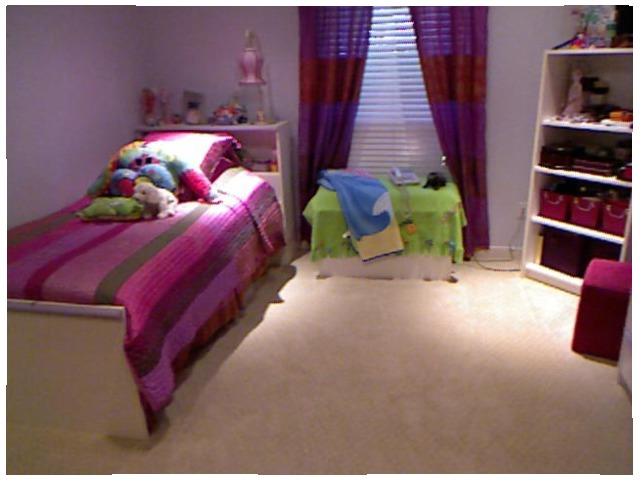<image>
Is the lamp on the rug? No. The lamp is not positioned on the rug. They may be near each other, but the lamp is not supported by or resting on top of the rug. 